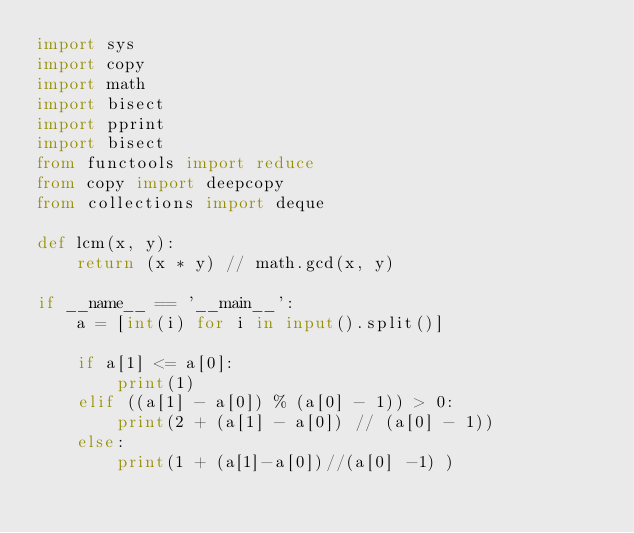<code> <loc_0><loc_0><loc_500><loc_500><_Python_>import sys
import copy
import math
import bisect
import pprint
import bisect
from functools import reduce
from copy import deepcopy
from collections import deque

def lcm(x, y):
    return (x * y) // math.gcd(x, y)

if __name__ == '__main__':
    a = [int(i) for i in input().split()]

    if a[1] <= a[0]:
        print(1)
    elif ((a[1] - a[0]) % (a[0] - 1)) > 0:
        print(2 + (a[1] - a[0]) // (a[0] - 1))
    else:
        print(1 + (a[1]-a[0])//(a[0] -1) )
</code> 